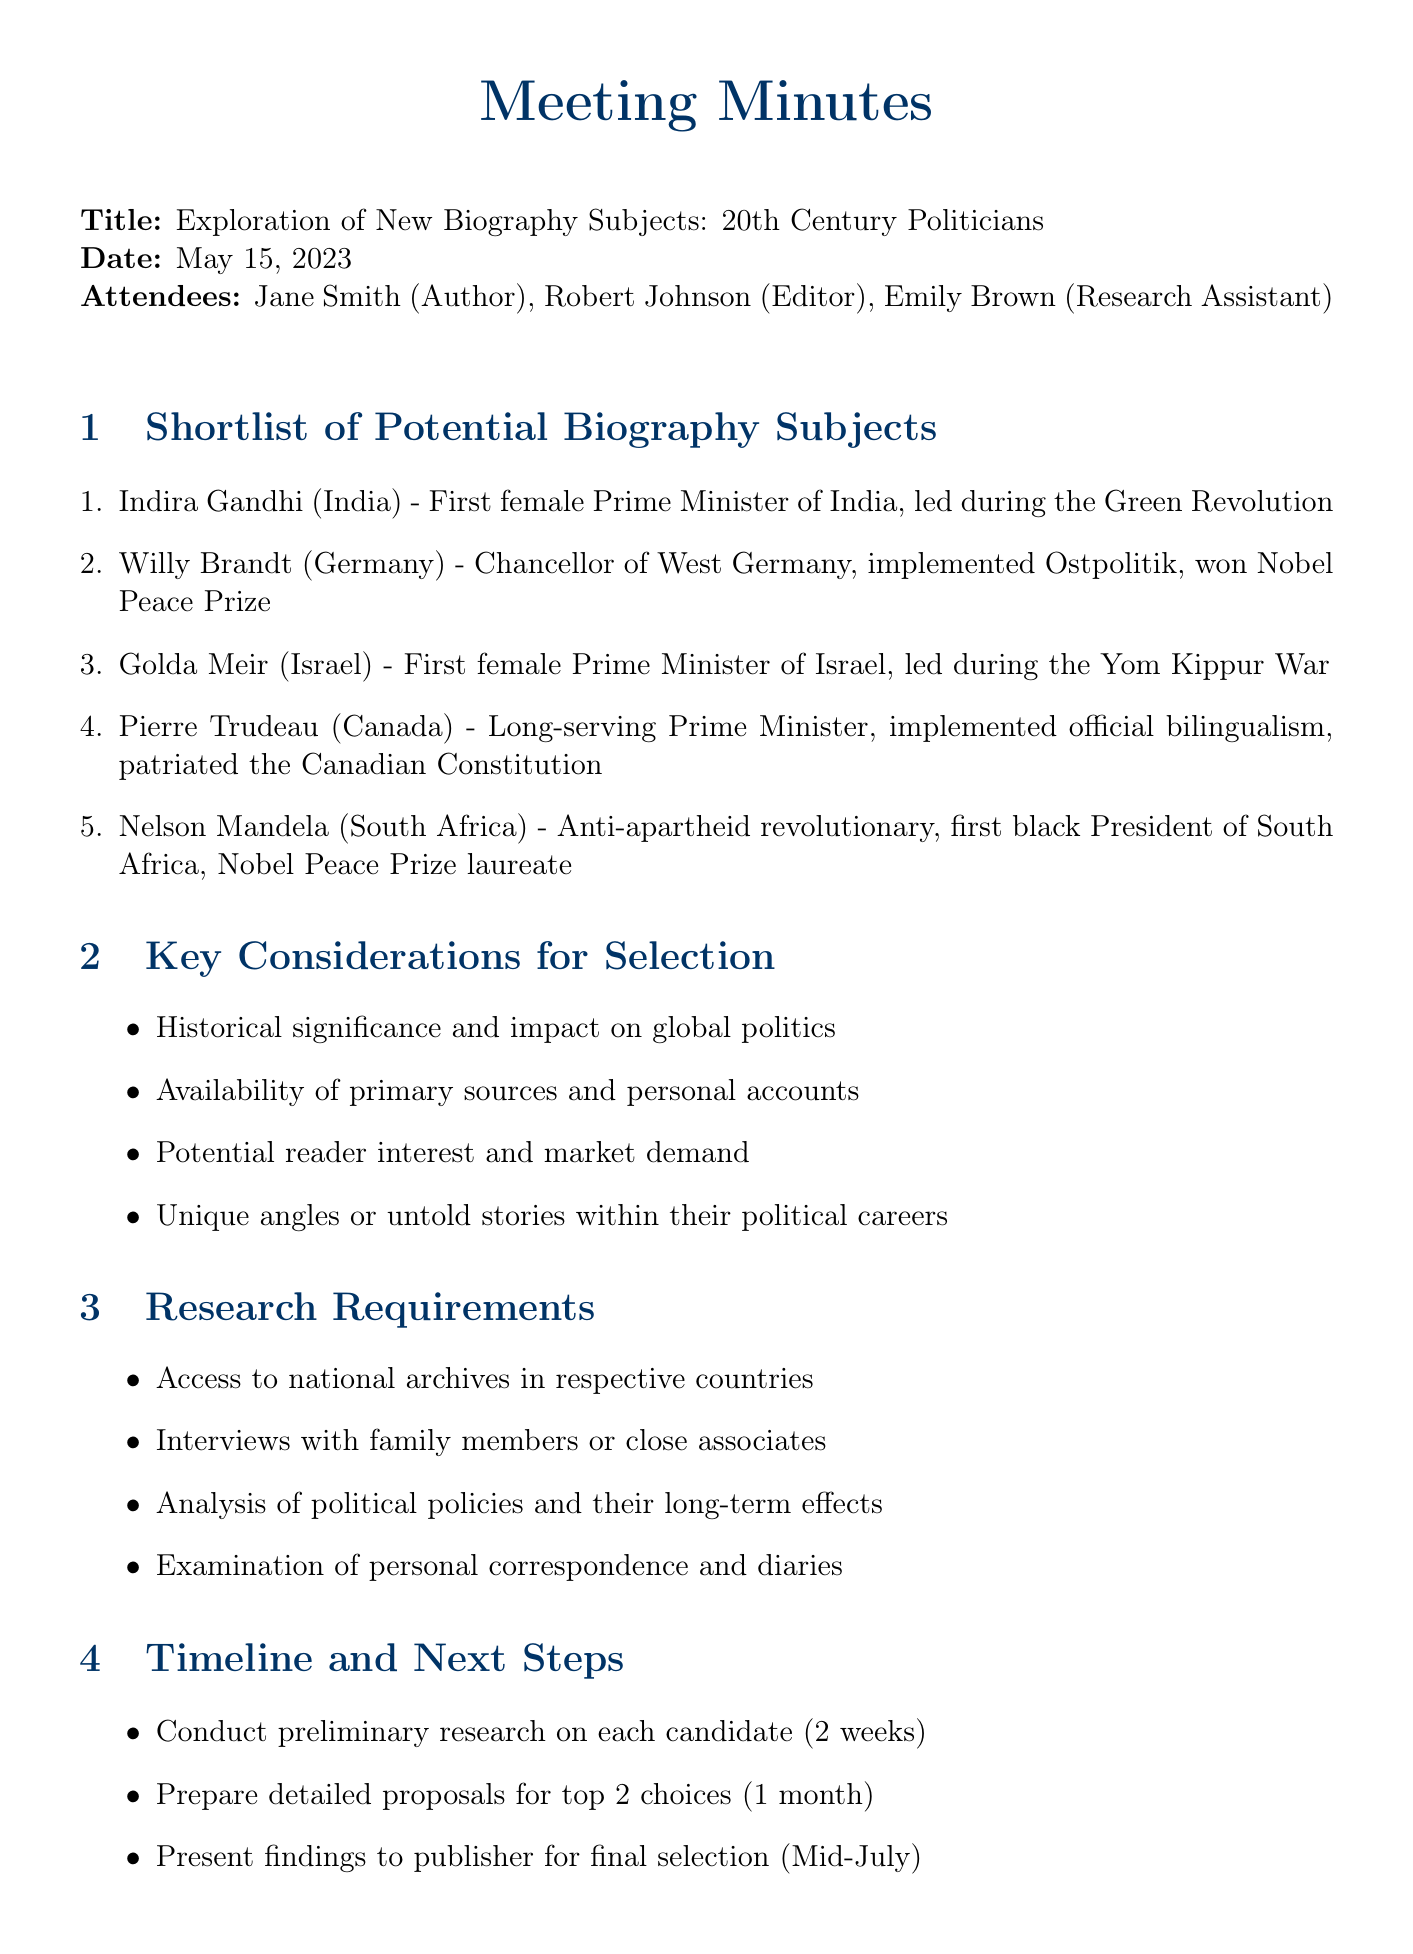What is the title of the meeting? The title of the meeting is clearly stated at the beginning of the document.
Answer: Exploration of New Biography Subjects: 20th Century Politicians Who is the first attendee listed? The first attendee is mentioned in the list of attendees.
Answer: Jane Smith (Author) When did the meeting take place? The date is specified in the document, providing a clear answer.
Answer: May 15, 2023 How many politicians are on the shortlist? The number of politicians is determined by counting the entries in the shortlist section.
Answer: 5 Which politician was the first female Prime Minister of Israel? This information can be found in the shortlist of potential biography subjects.
Answer: Golda Meir What is one key consideration for selecting biography subjects? Key considerations are listed in the relevant section of the document.
Answer: Historical significance and impact on global politics What will be presented to the publisher? The timeline section mentions what will be presented.
Answer: Findings for final selection How long is the preliminary research expected to take? The timeline section specifies how long preliminary research will take.
Answer: 2 weeks What is one research requirement listed? Research requirements are explicitly mentioned in their designated section.
Answer: Access to national archives in respective countries 